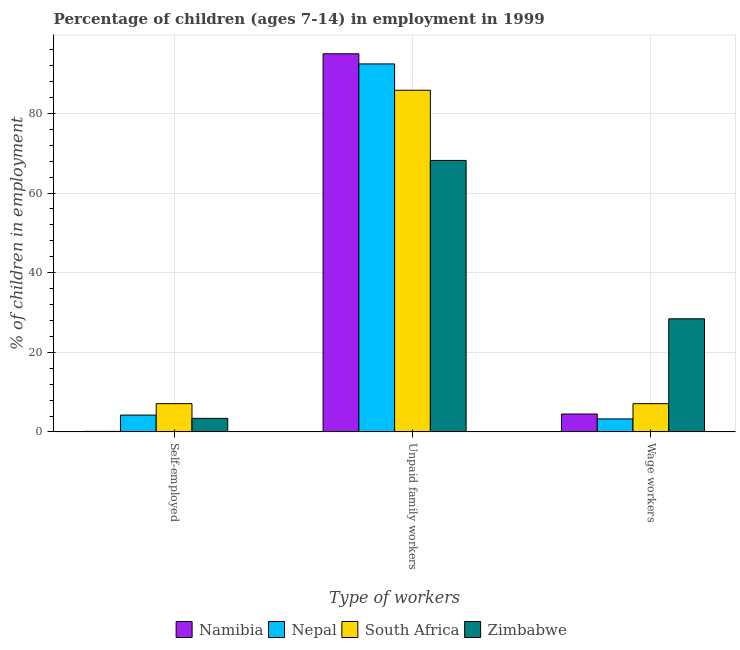How many different coloured bars are there?
Provide a short and direct response. 4. How many groups of bars are there?
Give a very brief answer. 3. How many bars are there on the 3rd tick from the right?
Your response must be concise. 4. What is the label of the 1st group of bars from the left?
Give a very brief answer. Self-employed. Across all countries, what is the maximum percentage of children employed as unpaid family workers?
Keep it short and to the point. 94.96. Across all countries, what is the minimum percentage of self employed children?
Make the answer very short. 0.14. In which country was the percentage of self employed children maximum?
Provide a short and direct response. South Africa. In which country was the percentage of children employed as wage workers minimum?
Make the answer very short. Nepal. What is the total percentage of self employed children in the graph?
Provide a succinct answer. 14.88. What is the difference between the percentage of children employed as wage workers in Zimbabwe and that in South Africa?
Keep it short and to the point. 21.31. What is the difference between the percentage of children employed as wage workers in South Africa and the percentage of children employed as unpaid family workers in Namibia?
Ensure brevity in your answer.  -87.86. What is the average percentage of self employed children per country?
Offer a terse response. 3.72. What is the difference between the percentage of children employed as unpaid family workers and percentage of self employed children in Nepal?
Make the answer very short. 88.18. In how many countries, is the percentage of self employed children greater than 92 %?
Keep it short and to the point. 0. What is the ratio of the percentage of children employed as unpaid family workers in Namibia to that in Nepal?
Provide a succinct answer. 1.03. Is the difference between the percentage of children employed as wage workers in South Africa and Zimbabwe greater than the difference between the percentage of self employed children in South Africa and Zimbabwe?
Offer a terse response. No. What is the difference between the highest and the second highest percentage of children employed as unpaid family workers?
Give a very brief answer. 2.55. What is the difference between the highest and the lowest percentage of self employed children?
Make the answer very short. 6.96. What does the 3rd bar from the left in Self-employed represents?
Your answer should be very brief. South Africa. What does the 1st bar from the right in Wage workers represents?
Ensure brevity in your answer.  Zimbabwe. Is it the case that in every country, the sum of the percentage of self employed children and percentage of children employed as unpaid family workers is greater than the percentage of children employed as wage workers?
Offer a terse response. Yes. How many bars are there?
Offer a very short reply. 12. Are all the bars in the graph horizontal?
Offer a very short reply. No. What is the difference between two consecutive major ticks on the Y-axis?
Provide a short and direct response. 20. Are the values on the major ticks of Y-axis written in scientific E-notation?
Make the answer very short. No. Where does the legend appear in the graph?
Provide a short and direct response. Bottom center. How many legend labels are there?
Offer a terse response. 4. How are the legend labels stacked?
Keep it short and to the point. Horizontal. What is the title of the graph?
Give a very brief answer. Percentage of children (ages 7-14) in employment in 1999. What is the label or title of the X-axis?
Offer a terse response. Type of workers. What is the label or title of the Y-axis?
Provide a short and direct response. % of children in employment. What is the % of children in employment of Namibia in Self-employed?
Your answer should be compact. 0.14. What is the % of children in employment in Nepal in Self-employed?
Ensure brevity in your answer.  4.23. What is the % of children in employment in Zimbabwe in Self-employed?
Your answer should be compact. 3.41. What is the % of children in employment of Namibia in Unpaid family workers?
Ensure brevity in your answer.  94.96. What is the % of children in employment in Nepal in Unpaid family workers?
Offer a terse response. 92.41. What is the % of children in employment of South Africa in Unpaid family workers?
Your answer should be very brief. 85.8. What is the % of children in employment in Zimbabwe in Unpaid family workers?
Ensure brevity in your answer.  68.18. What is the % of children in employment in Namibia in Wage workers?
Provide a short and direct response. 4.5. What is the % of children in employment of Nepal in Wage workers?
Your response must be concise. 3.27. What is the % of children in employment of South Africa in Wage workers?
Your answer should be very brief. 7.1. What is the % of children in employment in Zimbabwe in Wage workers?
Ensure brevity in your answer.  28.41. Across all Type of workers, what is the maximum % of children in employment in Namibia?
Give a very brief answer. 94.96. Across all Type of workers, what is the maximum % of children in employment in Nepal?
Your response must be concise. 92.41. Across all Type of workers, what is the maximum % of children in employment of South Africa?
Make the answer very short. 85.8. Across all Type of workers, what is the maximum % of children in employment of Zimbabwe?
Keep it short and to the point. 68.18. Across all Type of workers, what is the minimum % of children in employment of Namibia?
Your answer should be very brief. 0.14. Across all Type of workers, what is the minimum % of children in employment in Nepal?
Your answer should be compact. 3.27. Across all Type of workers, what is the minimum % of children in employment in Zimbabwe?
Offer a very short reply. 3.41. What is the total % of children in employment in Namibia in the graph?
Offer a terse response. 99.6. What is the total % of children in employment of Nepal in the graph?
Your response must be concise. 99.91. What is the total % of children in employment of Zimbabwe in the graph?
Make the answer very short. 100. What is the difference between the % of children in employment in Namibia in Self-employed and that in Unpaid family workers?
Offer a terse response. -94.82. What is the difference between the % of children in employment in Nepal in Self-employed and that in Unpaid family workers?
Provide a short and direct response. -88.18. What is the difference between the % of children in employment of South Africa in Self-employed and that in Unpaid family workers?
Your answer should be very brief. -78.7. What is the difference between the % of children in employment in Zimbabwe in Self-employed and that in Unpaid family workers?
Your response must be concise. -64.77. What is the difference between the % of children in employment in Namibia in Self-employed and that in Wage workers?
Give a very brief answer. -4.36. What is the difference between the % of children in employment in Namibia in Unpaid family workers and that in Wage workers?
Provide a short and direct response. 90.46. What is the difference between the % of children in employment in Nepal in Unpaid family workers and that in Wage workers?
Your answer should be compact. 89.14. What is the difference between the % of children in employment of South Africa in Unpaid family workers and that in Wage workers?
Your response must be concise. 78.7. What is the difference between the % of children in employment of Zimbabwe in Unpaid family workers and that in Wage workers?
Provide a succinct answer. 39.77. What is the difference between the % of children in employment of Namibia in Self-employed and the % of children in employment of Nepal in Unpaid family workers?
Ensure brevity in your answer.  -92.27. What is the difference between the % of children in employment of Namibia in Self-employed and the % of children in employment of South Africa in Unpaid family workers?
Ensure brevity in your answer.  -85.66. What is the difference between the % of children in employment in Namibia in Self-employed and the % of children in employment in Zimbabwe in Unpaid family workers?
Provide a short and direct response. -68.04. What is the difference between the % of children in employment in Nepal in Self-employed and the % of children in employment in South Africa in Unpaid family workers?
Keep it short and to the point. -81.57. What is the difference between the % of children in employment of Nepal in Self-employed and the % of children in employment of Zimbabwe in Unpaid family workers?
Your response must be concise. -63.95. What is the difference between the % of children in employment of South Africa in Self-employed and the % of children in employment of Zimbabwe in Unpaid family workers?
Ensure brevity in your answer.  -61.08. What is the difference between the % of children in employment of Namibia in Self-employed and the % of children in employment of Nepal in Wage workers?
Provide a succinct answer. -3.13. What is the difference between the % of children in employment of Namibia in Self-employed and the % of children in employment of South Africa in Wage workers?
Make the answer very short. -6.96. What is the difference between the % of children in employment in Namibia in Self-employed and the % of children in employment in Zimbabwe in Wage workers?
Offer a very short reply. -28.27. What is the difference between the % of children in employment of Nepal in Self-employed and the % of children in employment of South Africa in Wage workers?
Keep it short and to the point. -2.87. What is the difference between the % of children in employment in Nepal in Self-employed and the % of children in employment in Zimbabwe in Wage workers?
Ensure brevity in your answer.  -24.18. What is the difference between the % of children in employment in South Africa in Self-employed and the % of children in employment in Zimbabwe in Wage workers?
Provide a succinct answer. -21.31. What is the difference between the % of children in employment of Namibia in Unpaid family workers and the % of children in employment of Nepal in Wage workers?
Your response must be concise. 91.69. What is the difference between the % of children in employment in Namibia in Unpaid family workers and the % of children in employment in South Africa in Wage workers?
Provide a short and direct response. 87.86. What is the difference between the % of children in employment in Namibia in Unpaid family workers and the % of children in employment in Zimbabwe in Wage workers?
Keep it short and to the point. 66.55. What is the difference between the % of children in employment in Nepal in Unpaid family workers and the % of children in employment in South Africa in Wage workers?
Your answer should be compact. 85.31. What is the difference between the % of children in employment of Nepal in Unpaid family workers and the % of children in employment of Zimbabwe in Wage workers?
Provide a short and direct response. 64. What is the difference between the % of children in employment of South Africa in Unpaid family workers and the % of children in employment of Zimbabwe in Wage workers?
Your answer should be compact. 57.39. What is the average % of children in employment in Namibia per Type of workers?
Provide a succinct answer. 33.2. What is the average % of children in employment in Nepal per Type of workers?
Offer a very short reply. 33.3. What is the average % of children in employment of South Africa per Type of workers?
Give a very brief answer. 33.33. What is the average % of children in employment in Zimbabwe per Type of workers?
Your answer should be very brief. 33.33. What is the difference between the % of children in employment of Namibia and % of children in employment of Nepal in Self-employed?
Offer a terse response. -4.09. What is the difference between the % of children in employment in Namibia and % of children in employment in South Africa in Self-employed?
Offer a terse response. -6.96. What is the difference between the % of children in employment in Namibia and % of children in employment in Zimbabwe in Self-employed?
Offer a terse response. -3.27. What is the difference between the % of children in employment of Nepal and % of children in employment of South Africa in Self-employed?
Give a very brief answer. -2.87. What is the difference between the % of children in employment in Nepal and % of children in employment in Zimbabwe in Self-employed?
Offer a very short reply. 0.82. What is the difference between the % of children in employment in South Africa and % of children in employment in Zimbabwe in Self-employed?
Your answer should be very brief. 3.69. What is the difference between the % of children in employment of Namibia and % of children in employment of Nepal in Unpaid family workers?
Make the answer very short. 2.55. What is the difference between the % of children in employment in Namibia and % of children in employment in South Africa in Unpaid family workers?
Make the answer very short. 9.16. What is the difference between the % of children in employment in Namibia and % of children in employment in Zimbabwe in Unpaid family workers?
Give a very brief answer. 26.78. What is the difference between the % of children in employment of Nepal and % of children in employment of South Africa in Unpaid family workers?
Offer a very short reply. 6.61. What is the difference between the % of children in employment of Nepal and % of children in employment of Zimbabwe in Unpaid family workers?
Give a very brief answer. 24.23. What is the difference between the % of children in employment in South Africa and % of children in employment in Zimbabwe in Unpaid family workers?
Your answer should be very brief. 17.62. What is the difference between the % of children in employment in Namibia and % of children in employment in Nepal in Wage workers?
Your answer should be compact. 1.23. What is the difference between the % of children in employment of Namibia and % of children in employment of South Africa in Wage workers?
Offer a very short reply. -2.6. What is the difference between the % of children in employment of Namibia and % of children in employment of Zimbabwe in Wage workers?
Provide a short and direct response. -23.91. What is the difference between the % of children in employment of Nepal and % of children in employment of South Africa in Wage workers?
Your response must be concise. -3.83. What is the difference between the % of children in employment of Nepal and % of children in employment of Zimbabwe in Wage workers?
Your answer should be very brief. -25.14. What is the difference between the % of children in employment of South Africa and % of children in employment of Zimbabwe in Wage workers?
Keep it short and to the point. -21.31. What is the ratio of the % of children in employment of Namibia in Self-employed to that in Unpaid family workers?
Your answer should be very brief. 0. What is the ratio of the % of children in employment in Nepal in Self-employed to that in Unpaid family workers?
Ensure brevity in your answer.  0.05. What is the ratio of the % of children in employment of South Africa in Self-employed to that in Unpaid family workers?
Provide a succinct answer. 0.08. What is the ratio of the % of children in employment in Namibia in Self-employed to that in Wage workers?
Your answer should be compact. 0.03. What is the ratio of the % of children in employment in Nepal in Self-employed to that in Wage workers?
Your answer should be compact. 1.29. What is the ratio of the % of children in employment of South Africa in Self-employed to that in Wage workers?
Your response must be concise. 1. What is the ratio of the % of children in employment in Zimbabwe in Self-employed to that in Wage workers?
Keep it short and to the point. 0.12. What is the ratio of the % of children in employment in Namibia in Unpaid family workers to that in Wage workers?
Keep it short and to the point. 21.1. What is the ratio of the % of children in employment of Nepal in Unpaid family workers to that in Wage workers?
Your answer should be compact. 28.26. What is the ratio of the % of children in employment in South Africa in Unpaid family workers to that in Wage workers?
Provide a short and direct response. 12.08. What is the ratio of the % of children in employment in Zimbabwe in Unpaid family workers to that in Wage workers?
Make the answer very short. 2.4. What is the difference between the highest and the second highest % of children in employment in Namibia?
Keep it short and to the point. 90.46. What is the difference between the highest and the second highest % of children in employment in Nepal?
Make the answer very short. 88.18. What is the difference between the highest and the second highest % of children in employment of South Africa?
Offer a very short reply. 78.7. What is the difference between the highest and the second highest % of children in employment of Zimbabwe?
Offer a very short reply. 39.77. What is the difference between the highest and the lowest % of children in employment in Namibia?
Your response must be concise. 94.82. What is the difference between the highest and the lowest % of children in employment of Nepal?
Give a very brief answer. 89.14. What is the difference between the highest and the lowest % of children in employment in South Africa?
Keep it short and to the point. 78.7. What is the difference between the highest and the lowest % of children in employment of Zimbabwe?
Give a very brief answer. 64.77. 